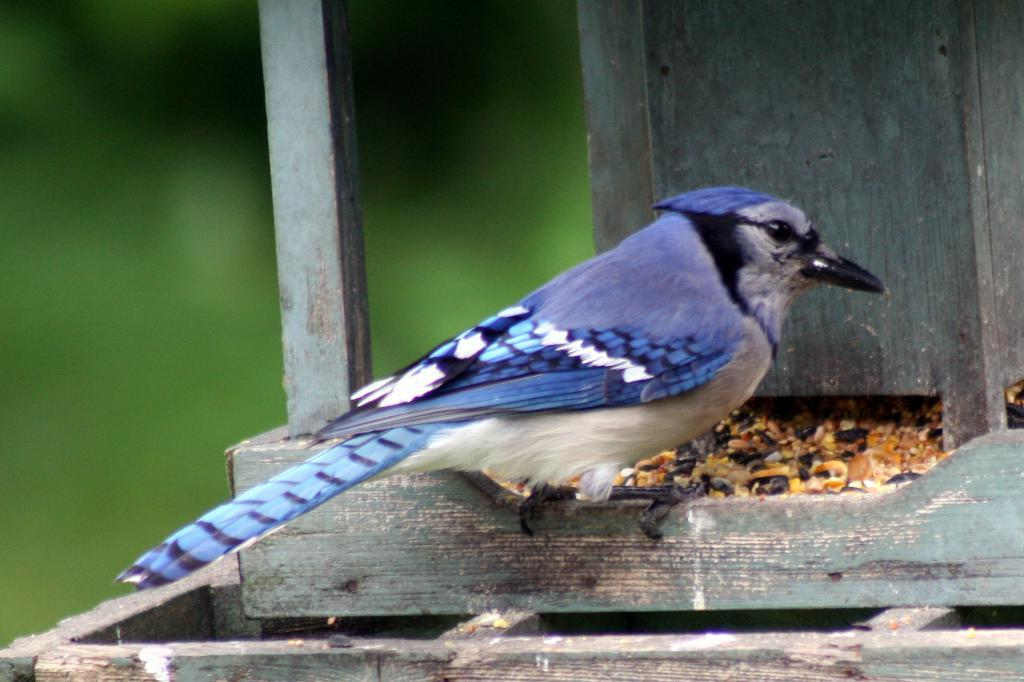What is the main subject in the center of the image? There is a bird in the center of the image. What is located near the bird in the center of the image? There are seeds in the center of the image. What type of material can be seen in the background of the image? There is wood visible in the background of the image. How would you describe the clarity of the left side of the image? The left side of the image is blurred. How many mountains can be seen in the background of the image? There are no mountains visible in the background of the image; it features wood instead. 